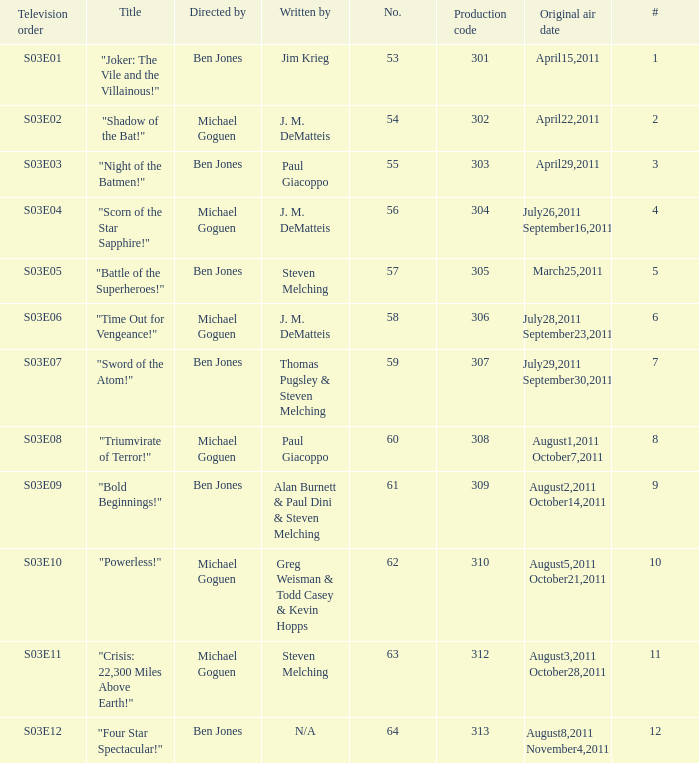What is the original air date of the episode directed by ben jones and written by steven melching?  March25,2011. 